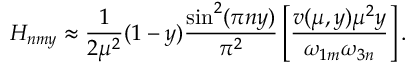Convert formula to latex. <formula><loc_0><loc_0><loc_500><loc_500>H _ { n m y } \approx \frac { 1 } { 2 \mu ^ { 2 } } ( 1 - y ) \frac { \sin ^ { 2 } ( \pi n y ) } { \pi ^ { 2 } } \left [ \frac { v ( \mu , y ) \mu ^ { 2 } y } { \omega _ { 1 m } \omega _ { 3 n } } \right ] .</formula> 